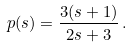Convert formula to latex. <formula><loc_0><loc_0><loc_500><loc_500>p ( s ) = \frac { 3 ( s + 1 ) } { 2 s + 3 } \, .</formula> 